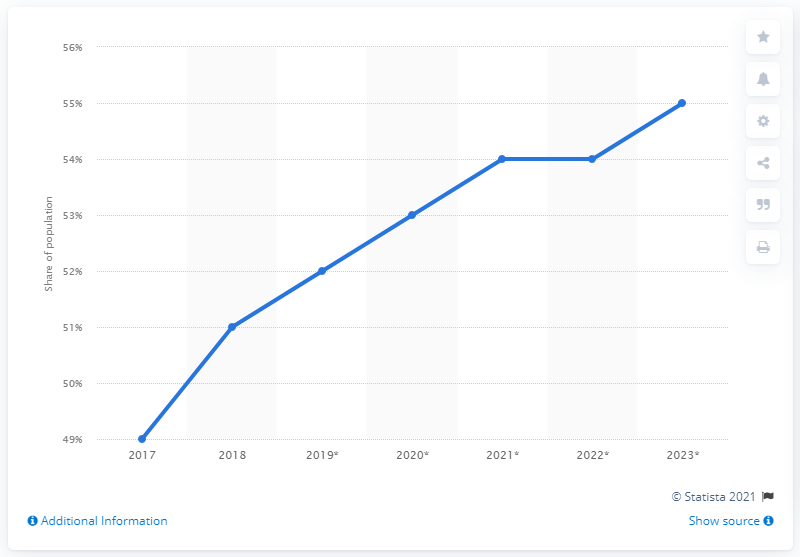Identify some key points in this picture. In 2017, the social media penetration in the Philippines was 49%. 